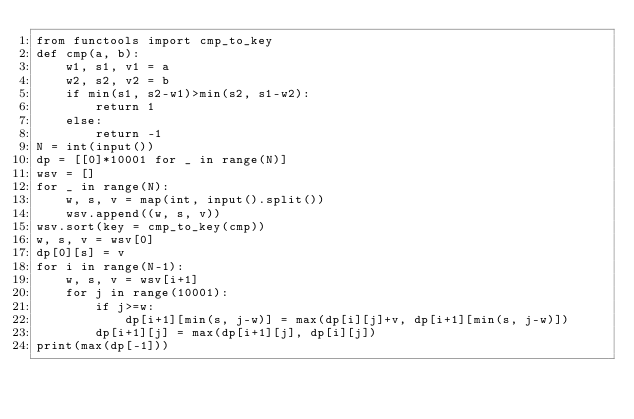Convert code to text. <code><loc_0><loc_0><loc_500><loc_500><_Python_>from functools import cmp_to_key
def cmp(a, b):
    w1, s1, v1 = a
    w2, s2, v2 = b
    if min(s1, s2-w1)>min(s2, s1-w2):
        return 1
    else:
        return -1
N = int(input())
dp = [[0]*10001 for _ in range(N)]
wsv = []
for _ in range(N):
    w, s, v = map(int, input().split())
    wsv.append((w, s, v))
wsv.sort(key = cmp_to_key(cmp))
w, s, v = wsv[0]
dp[0][s] = v
for i in range(N-1):
    w, s, v = wsv[i+1]
    for j in range(10001):
        if j>=w:
            dp[i+1][min(s, j-w)] = max(dp[i][j]+v, dp[i+1][min(s, j-w)])
        dp[i+1][j] = max(dp[i+1][j], dp[i][j])
print(max(dp[-1]))


</code> 